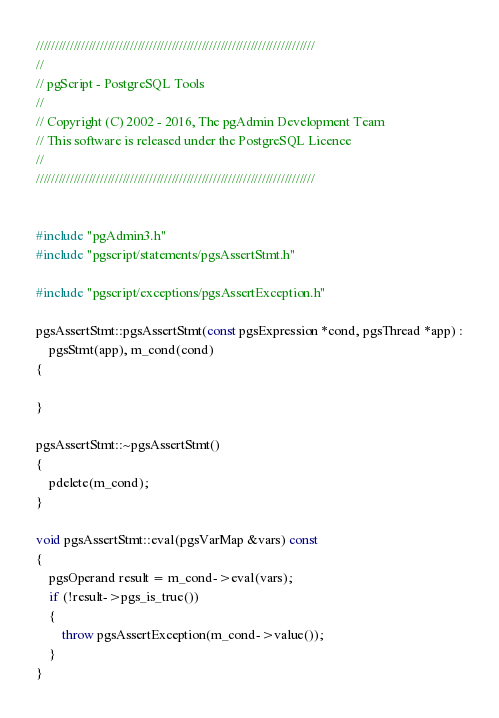<code> <loc_0><loc_0><loc_500><loc_500><_C++_>//////////////////////////////////////////////////////////////////////////
//
// pgScript - PostgreSQL Tools
//
// Copyright (C) 2002 - 2016, The pgAdmin Development Team
// This software is released under the PostgreSQL Licence
//
//////////////////////////////////////////////////////////////////////////


#include "pgAdmin3.h"
#include "pgscript/statements/pgsAssertStmt.h"

#include "pgscript/exceptions/pgsAssertException.h"

pgsAssertStmt::pgsAssertStmt(const pgsExpression *cond, pgsThread *app) :
	pgsStmt(app), m_cond(cond)
{

}

pgsAssertStmt::~pgsAssertStmt()
{
	pdelete(m_cond);
}

void pgsAssertStmt::eval(pgsVarMap &vars) const
{
	pgsOperand result = m_cond->eval(vars);
	if (!result->pgs_is_true())
	{
		throw pgsAssertException(m_cond->value());
	}
}
</code> 